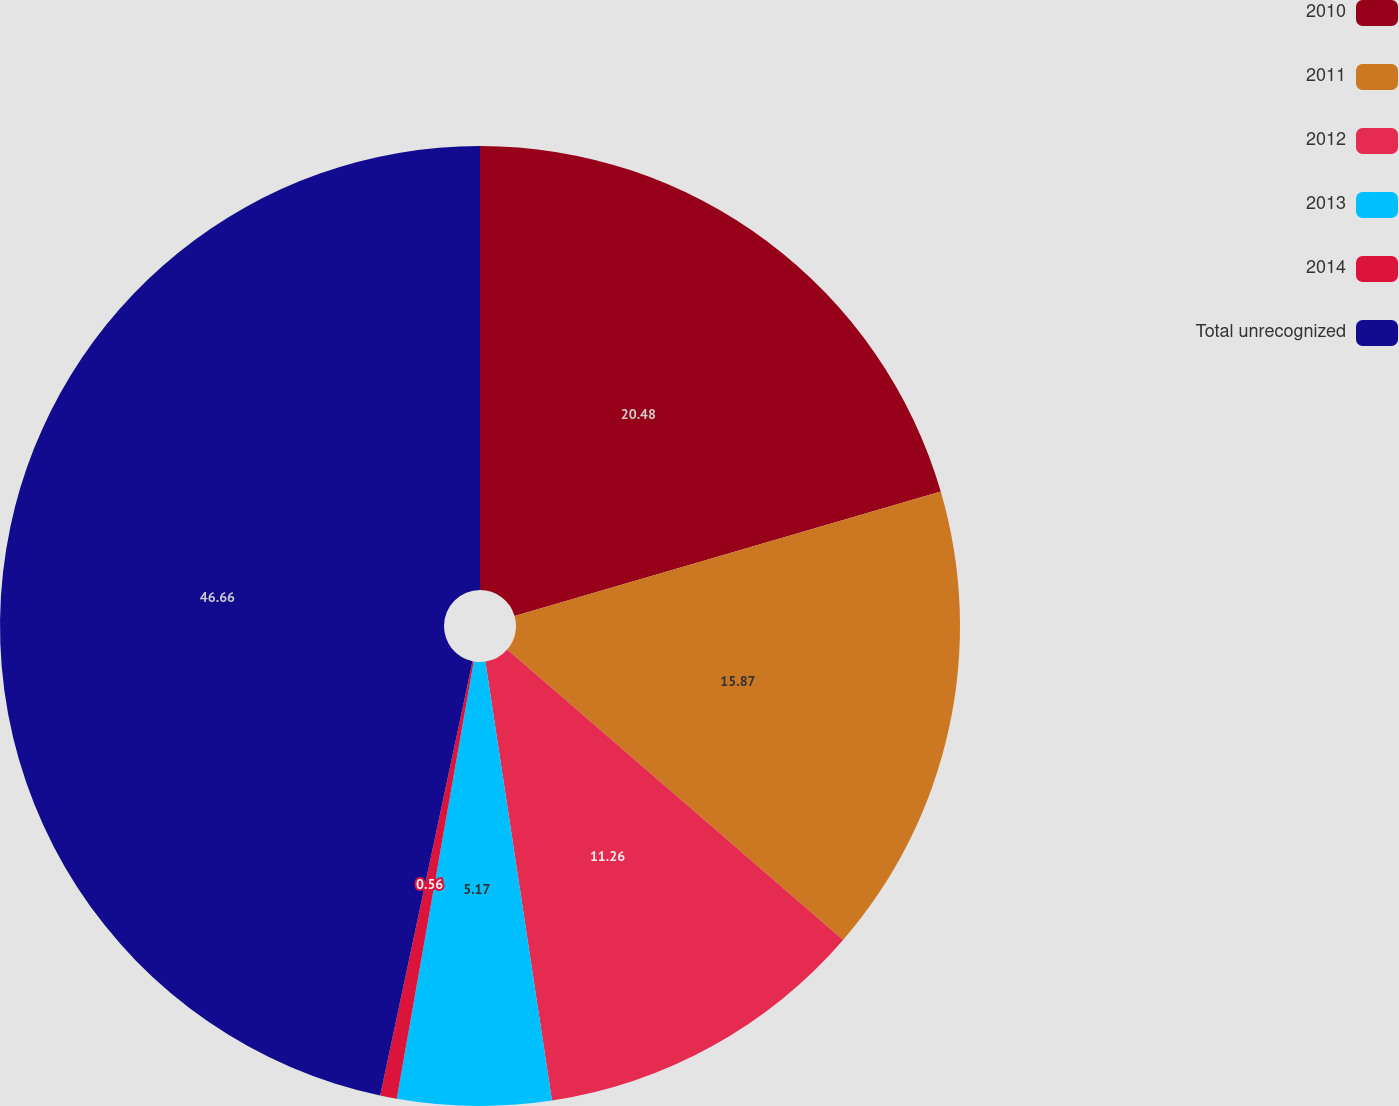<chart> <loc_0><loc_0><loc_500><loc_500><pie_chart><fcel>2010<fcel>2011<fcel>2012<fcel>2013<fcel>2014<fcel>Total unrecognized<nl><fcel>20.48%<fcel>15.87%<fcel>11.26%<fcel>5.17%<fcel>0.56%<fcel>46.67%<nl></chart> 